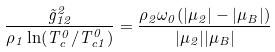<formula> <loc_0><loc_0><loc_500><loc_500>\frac { \tilde { g } _ { 1 2 } ^ { 2 } } { \rho _ { 1 } \ln ( T _ { c } ^ { 0 } / T _ { c 1 } ^ { 0 } ) } = \frac { \rho _ { 2 } \omega _ { 0 } ( | \mu _ { 2 } | - | \mu _ { B } | ) } { | \mu _ { 2 } | | \mu _ { B } | }</formula> 